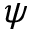Convert formula to latex. <formula><loc_0><loc_0><loc_500><loc_500>\psi</formula> 